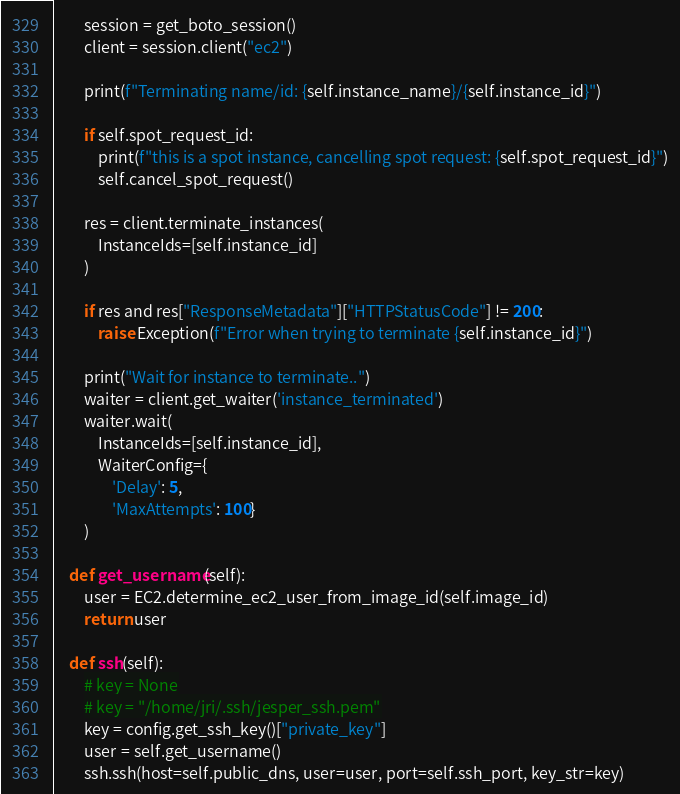<code> <loc_0><loc_0><loc_500><loc_500><_Python_>        session = get_boto_session()
        client = session.client("ec2")

        print(f"Terminating name/id: {self.instance_name}/{self.instance_id}")

        if self.spot_request_id:
            print(f"this is a spot instance, cancelling spot request: {self.spot_request_id}")
            self.cancel_spot_request()

        res = client.terminate_instances(
            InstanceIds=[self.instance_id]
        )

        if res and res["ResponseMetadata"]["HTTPStatusCode"] != 200:
            raise Exception(f"Error when trying to terminate {self.instance_id}")

        print("Wait for instance to terminate..")
        waiter = client.get_waiter('instance_terminated')
        waiter.wait(
            InstanceIds=[self.instance_id],
            WaiterConfig={
                'Delay': 5,
                'MaxAttempts': 100}
        )

    def get_username(self):
        user = EC2.determine_ec2_user_from_image_id(self.image_id)
        return user

    def ssh(self):
        # key = None
        # key = "/home/jri/.ssh/jesper_ssh.pem"
        key = config.get_ssh_key()["private_key"]
        user = self.get_username()
        ssh.ssh(host=self.public_dns, user=user, port=self.ssh_port, key_str=key)
</code> 